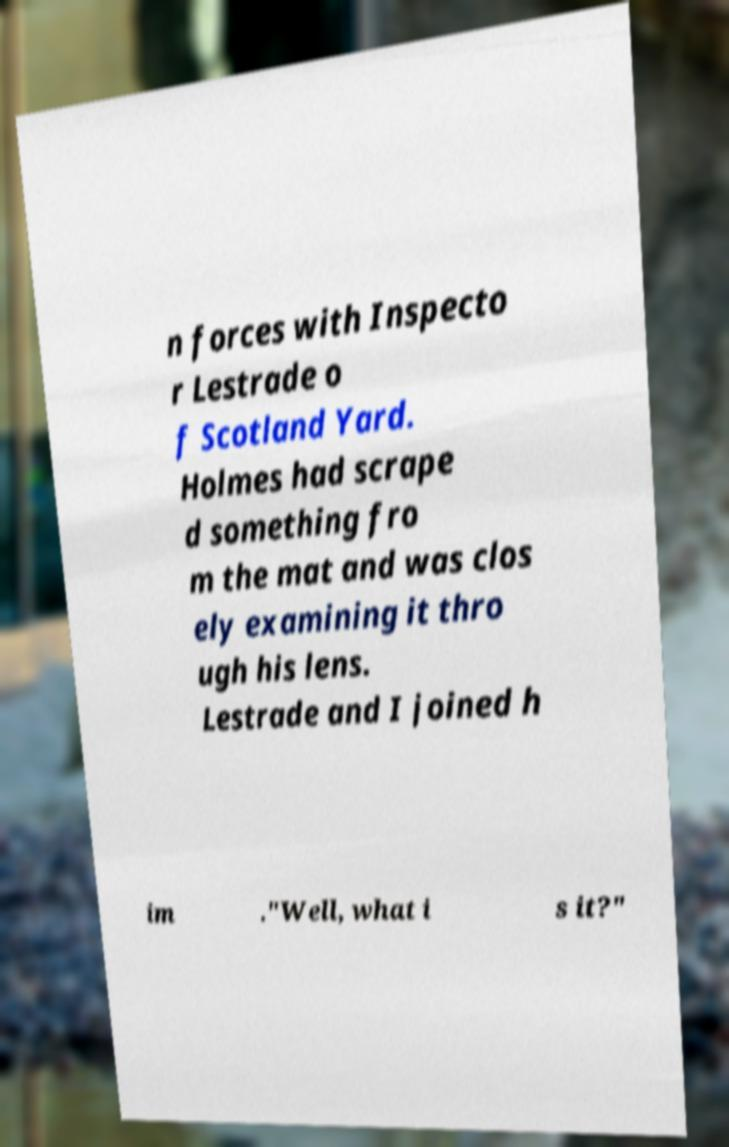Please read and relay the text visible in this image. What does it say? n forces with Inspecto r Lestrade o f Scotland Yard. Holmes had scrape d something fro m the mat and was clos ely examining it thro ugh his lens. Lestrade and I joined h im ."Well, what i s it?" 